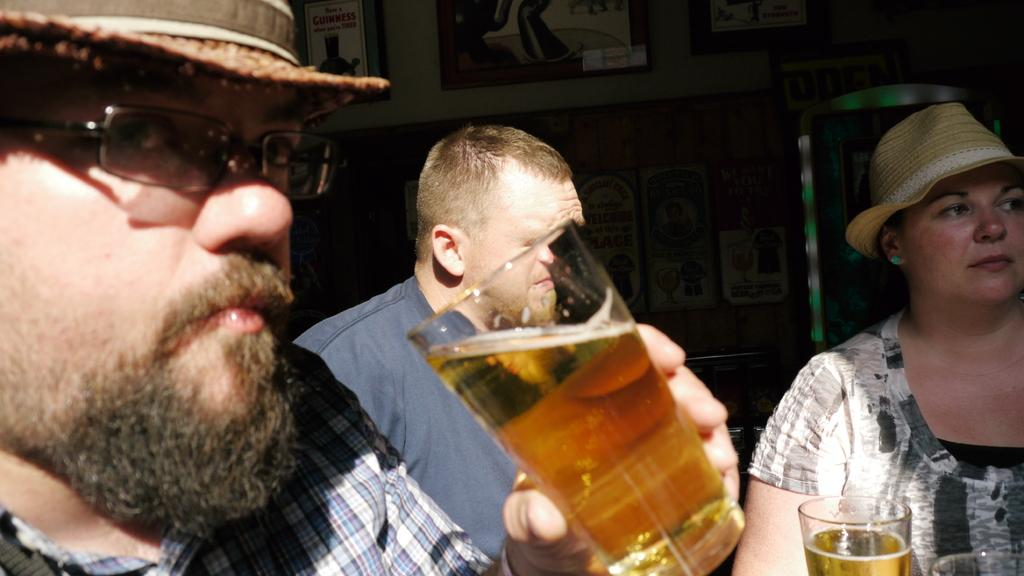How many people are sitting in the image? There are three people sitting in the image. What are the people on the left and right wearing? The person on the left and the person on the right are both wearing hats. What is the person on the left holding? The person on the left is holding a glass of a drink. What can be seen on the wall behind the people? There are photo frames on the wall behind the people. What type of meal is being served to the dinosaurs in the image? There are no dinosaurs present in the image, so it is not possible to determine what type of meal might be served to them. 